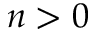Convert formula to latex. <formula><loc_0><loc_0><loc_500><loc_500>n > 0</formula> 